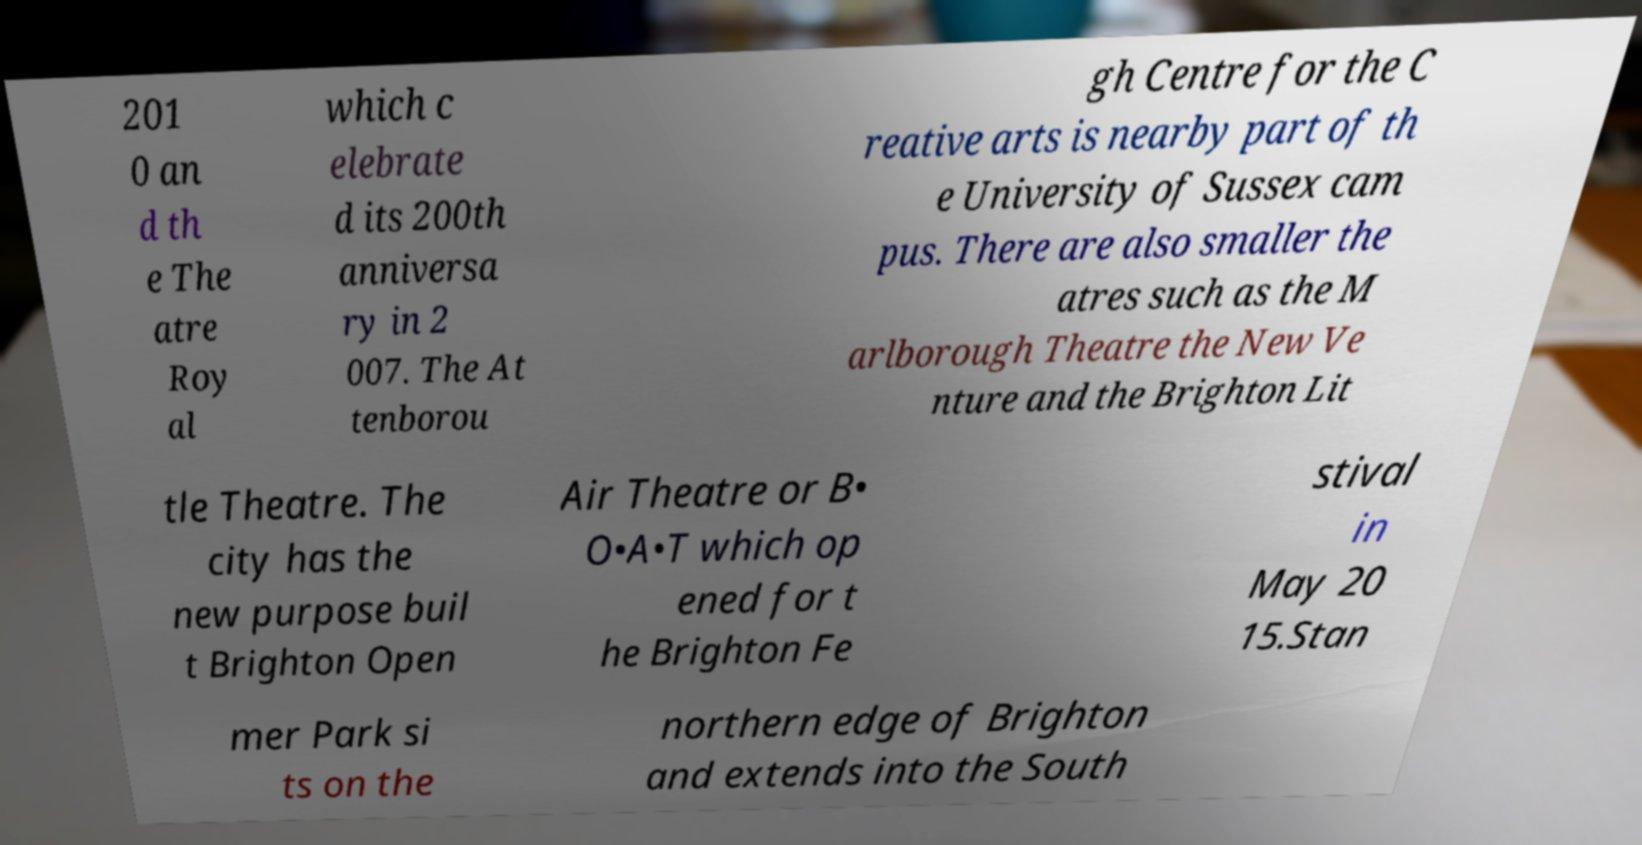What messages or text are displayed in this image? I need them in a readable, typed format. 201 0 an d th e The atre Roy al which c elebrate d its 200th anniversa ry in 2 007. The At tenborou gh Centre for the C reative arts is nearby part of th e University of Sussex cam pus. There are also smaller the atres such as the M arlborough Theatre the New Ve nture and the Brighton Lit tle Theatre. The city has the new purpose buil t Brighton Open Air Theatre or B• O•A•T which op ened for t he Brighton Fe stival in May 20 15.Stan mer Park si ts on the northern edge of Brighton and extends into the South 